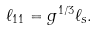<formula> <loc_0><loc_0><loc_500><loc_500>\ell _ { 1 1 } = g ^ { 1 / 3 } \ell _ { s } .</formula> 